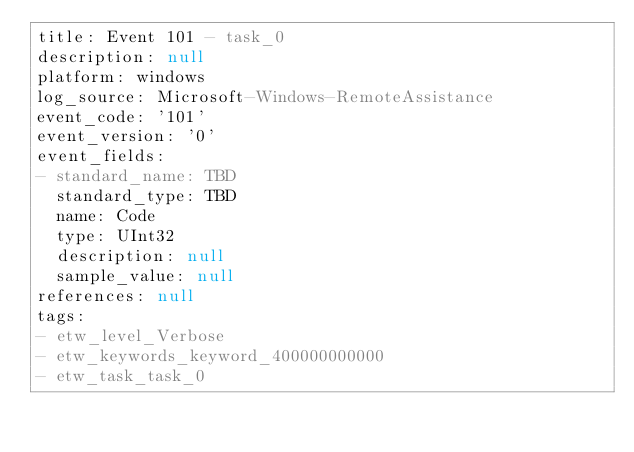<code> <loc_0><loc_0><loc_500><loc_500><_YAML_>title: Event 101 - task_0
description: null
platform: windows
log_source: Microsoft-Windows-RemoteAssistance
event_code: '101'
event_version: '0'
event_fields:
- standard_name: TBD
  standard_type: TBD
  name: Code
  type: UInt32
  description: null
  sample_value: null
references: null
tags:
- etw_level_Verbose
- etw_keywords_keyword_400000000000
- etw_task_task_0
</code> 